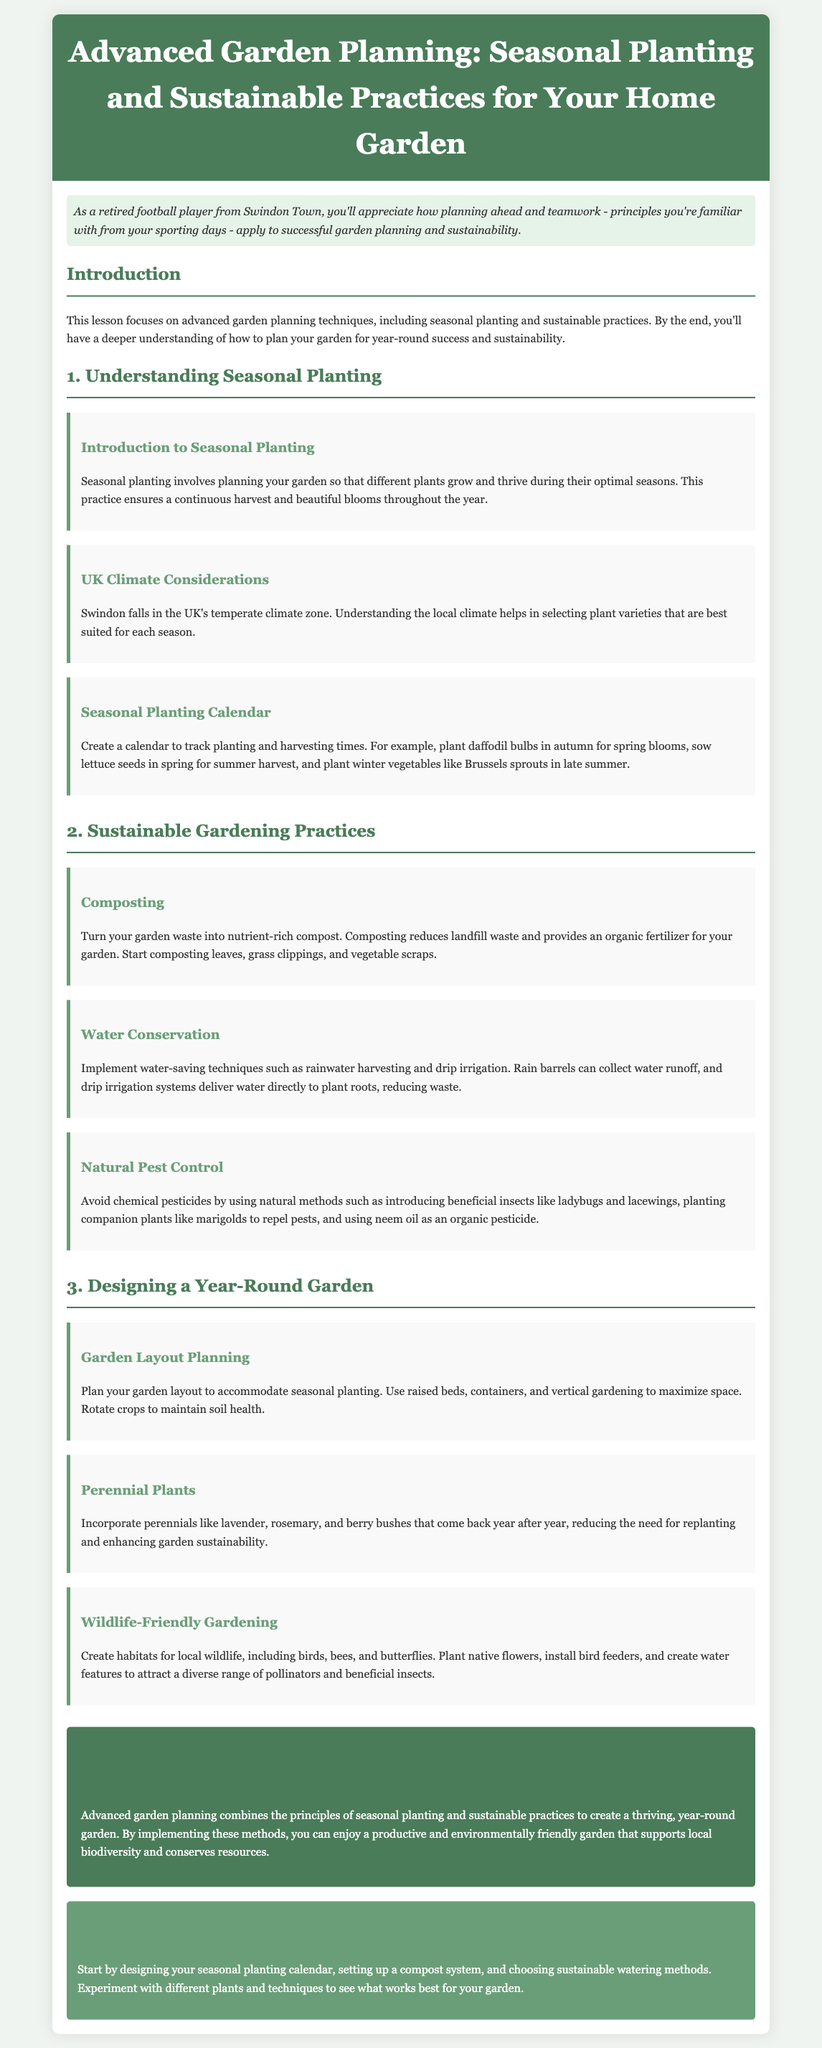what is the main focus of the lesson? The lesson focuses on advanced garden planning techniques, including seasonal planting and sustainable practices.
Answer: advanced garden planning techniques what type of garden practices are discussed in section 2? Section 2 discusses sustainable gardening practices.
Answer: sustainable gardening practices what should you plant in autumn for spring blooms? The document suggests planting daffodil bulbs in autumn for spring blooms.
Answer: daffodil bulbs which climate zone does Swindon fall under? Swindon falls in the UK's temperate climate zone.
Answer: temperate climate zone what is one benefit of composting mentioned in the document? Composting reduces landfill waste and provides an organic fertilizer for your garden.
Answer: reduces landfill waste how can you implement water conservation in your garden? The lesson mentions techniques such as rainwater harvesting and drip irrigation.
Answer: rainwater harvesting what are two examples of perennial plants? The document lists lavender and rosemary as examples of perennials.
Answer: lavender, rosemary what is a suggested action for creating wildlife-friendly gardening? Plant native flowers to attract a diverse range of pollinators and beneficial insects.
Answer: plant native flowers what does the conclusion of the lesson emphasize? The conclusion emphasizes that advanced garden planning combines seasonal planting and sustainable practices.
Answer: advanced garden planning combines seasonal planting and sustainable practices 